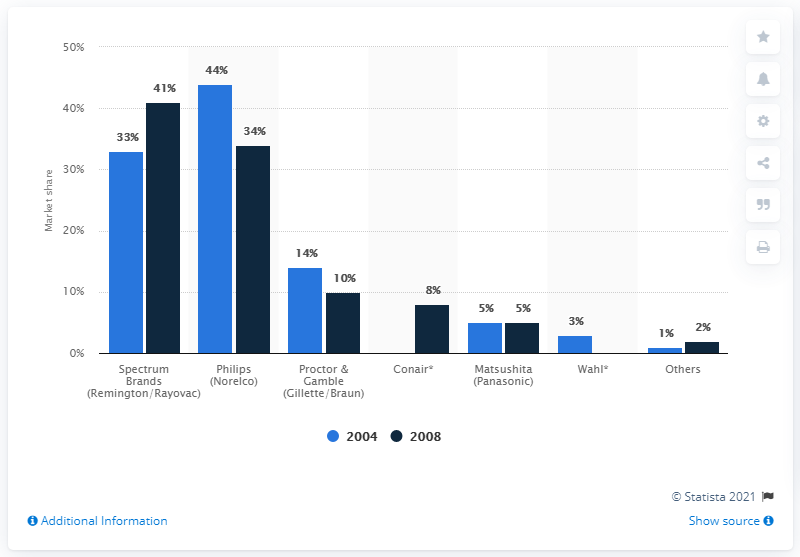Specify some key components in this picture. Spectrum Brands held 41% of the U.S. electric shaver market in 2008. 